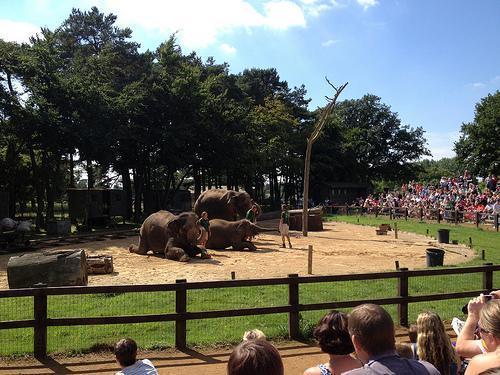How many of the fence posts in this image are to the left of all the elephants?
Give a very brief answer. 1. 